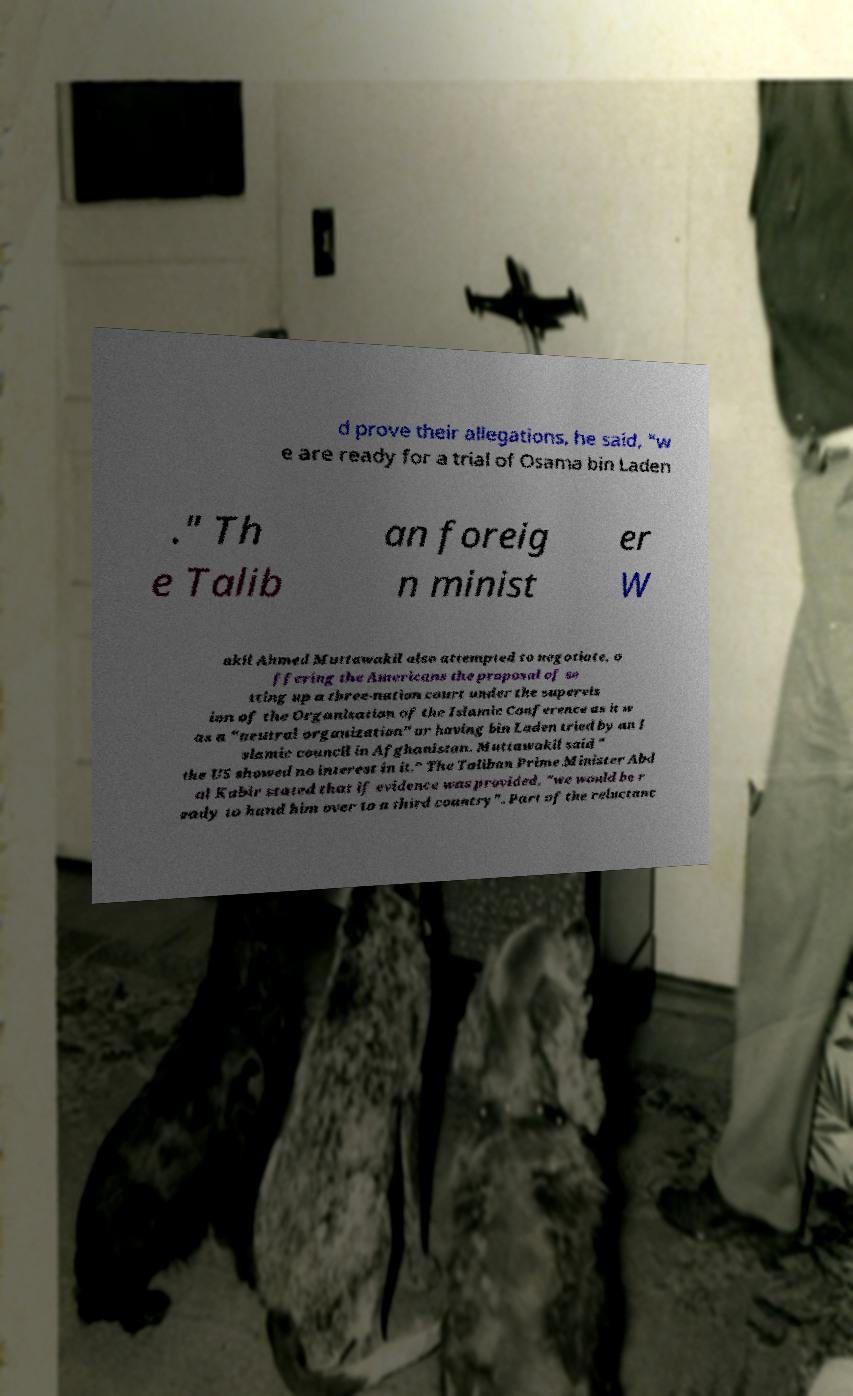For documentation purposes, I need the text within this image transcribed. Could you provide that? d prove their allegations, he said, "w e are ready for a trial of Osama bin Laden ." Th e Talib an foreig n minist er W akil Ahmed Muttawakil also attempted to negotiate, o ffering the Americans the proposal of se tting up a three-nation court under the supervis ion of the Organisation of the Islamic Conference as it w as a "neutral organization" or having bin Laden tried by an I slamic council in Afghanistan. Muttawakil said " the US showed no interest in it." The Taliban Prime Minister Abd ul Kabir stated that if evidence was provided, "we would be r eady to hand him over to a third country". Part of the reluctanc 